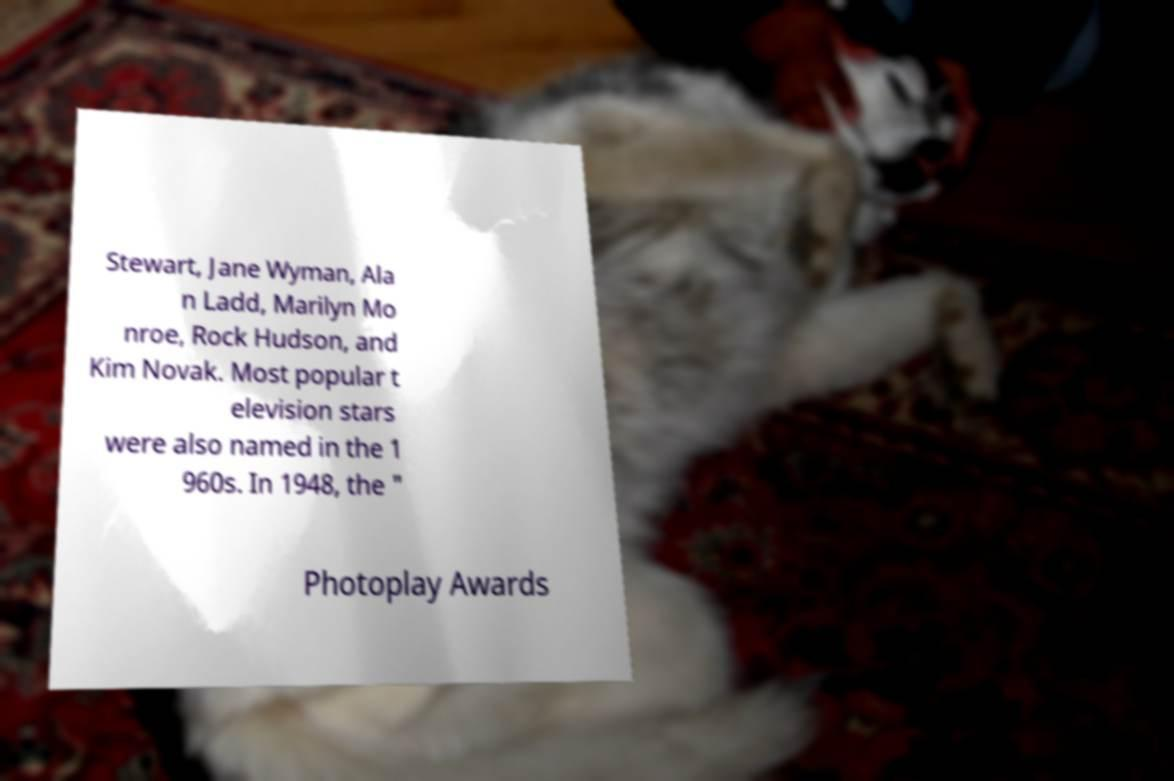Can you accurately transcribe the text from the provided image for me? Stewart, Jane Wyman, Ala n Ladd, Marilyn Mo nroe, Rock Hudson, and Kim Novak. Most popular t elevision stars were also named in the 1 960s. In 1948, the " Photoplay Awards 